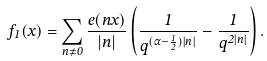<formula> <loc_0><loc_0><loc_500><loc_500>f _ { 1 } ( x ) = \sum _ { n \neq 0 } \frac { e ( n x ) } { | n | } \left ( \frac { 1 } { q ^ { ( \alpha - \frac { 1 } { 2 } ) | n | } } - \frac { 1 } { q ^ { 2 | n | } } \right ) .</formula> 